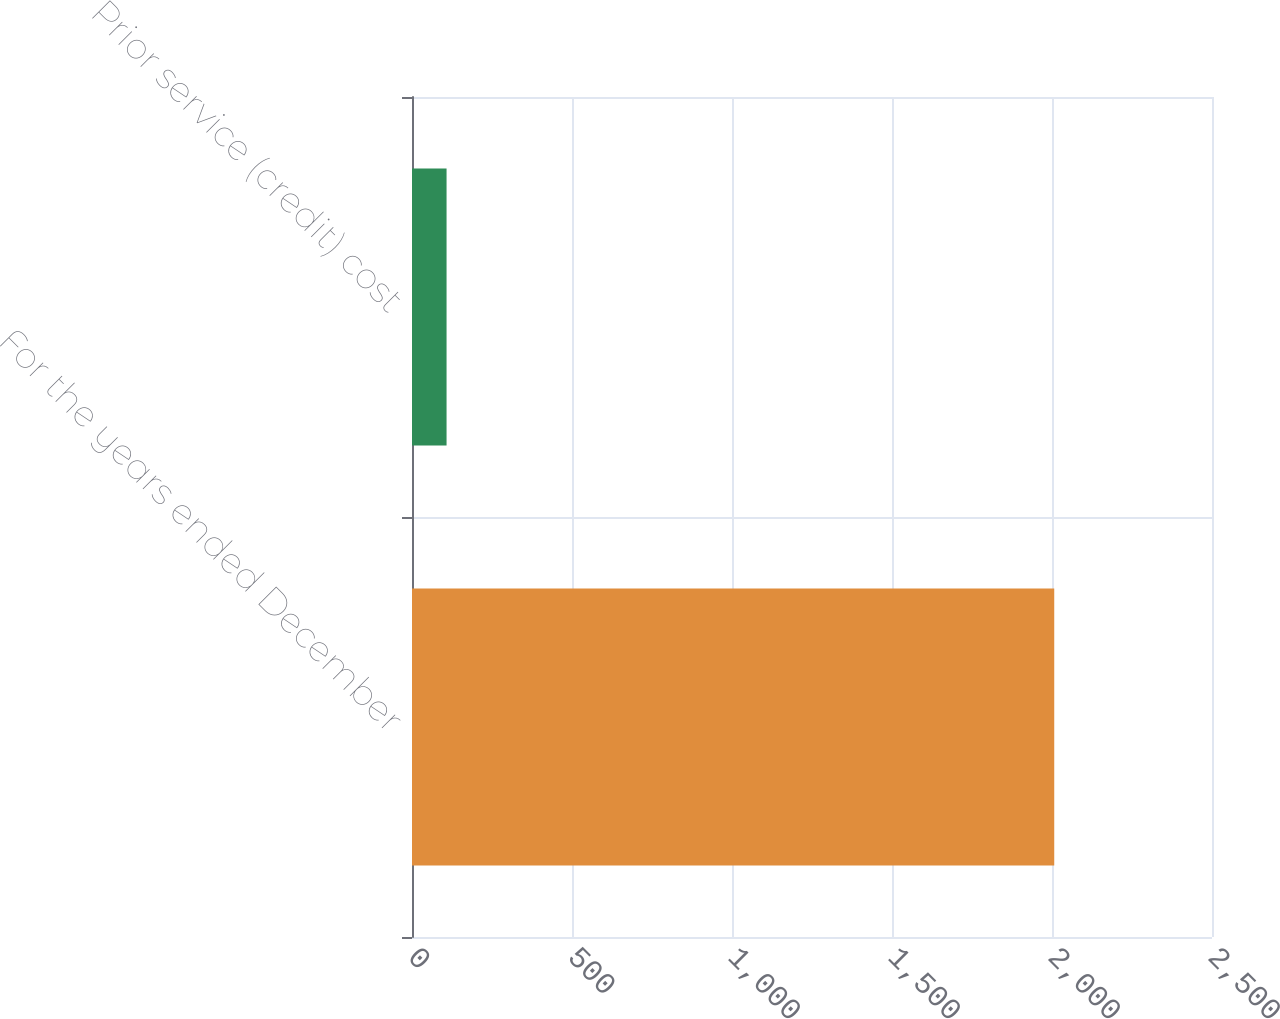Convert chart to OTSL. <chart><loc_0><loc_0><loc_500><loc_500><bar_chart><fcel>For the years ended December<fcel>Prior service (credit) cost<nl><fcel>2007<fcel>108<nl></chart> 